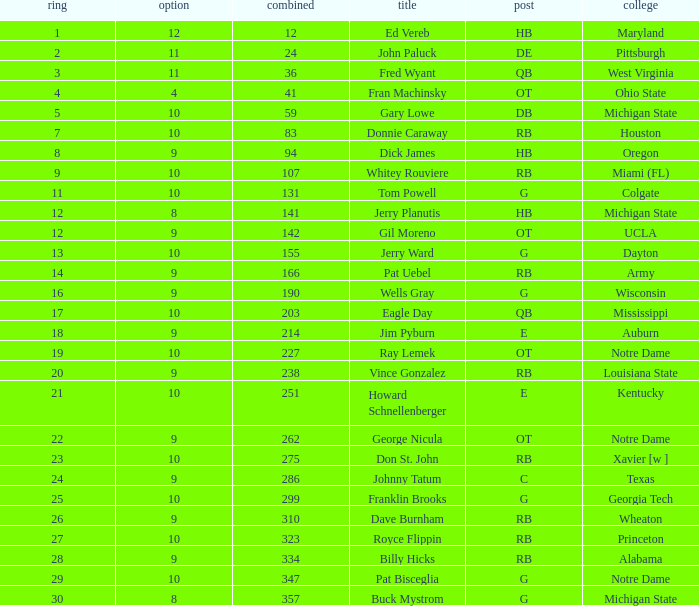What is the highest overall pick number for george nicula who had a pick smaller than 9? None. 